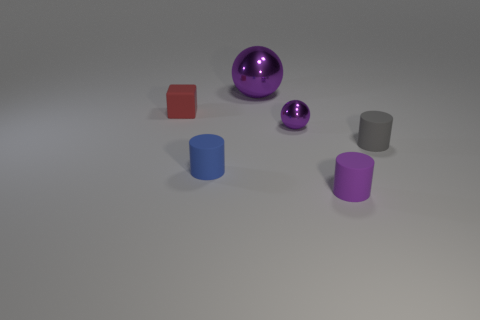There is a blue rubber object that is the same shape as the gray thing; what is its size?
Offer a very short reply. Small. Are there any other things that have the same shape as the red rubber thing?
Your response must be concise. No. What is the material of the cylinder that is the same color as the large shiny ball?
Provide a succinct answer. Rubber. Is the number of small purple matte cylinders in front of the tiny purple metallic object the same as the number of large blue shiny blocks?
Your answer should be compact. No. There is a red block; are there any large spheres to the right of it?
Provide a short and direct response. Yes. Do the small gray rubber object and the tiny rubber thing behind the gray matte cylinder have the same shape?
Make the answer very short. No. The cube that is the same material as the gray cylinder is what color?
Ensure brevity in your answer.  Red. What is the color of the small metal object?
Ensure brevity in your answer.  Purple. Is the tiny blue cylinder made of the same material as the object that is behind the red thing?
Provide a succinct answer. No. How many purple things are in front of the red rubber object and behind the tiny purple sphere?
Ensure brevity in your answer.  0. 